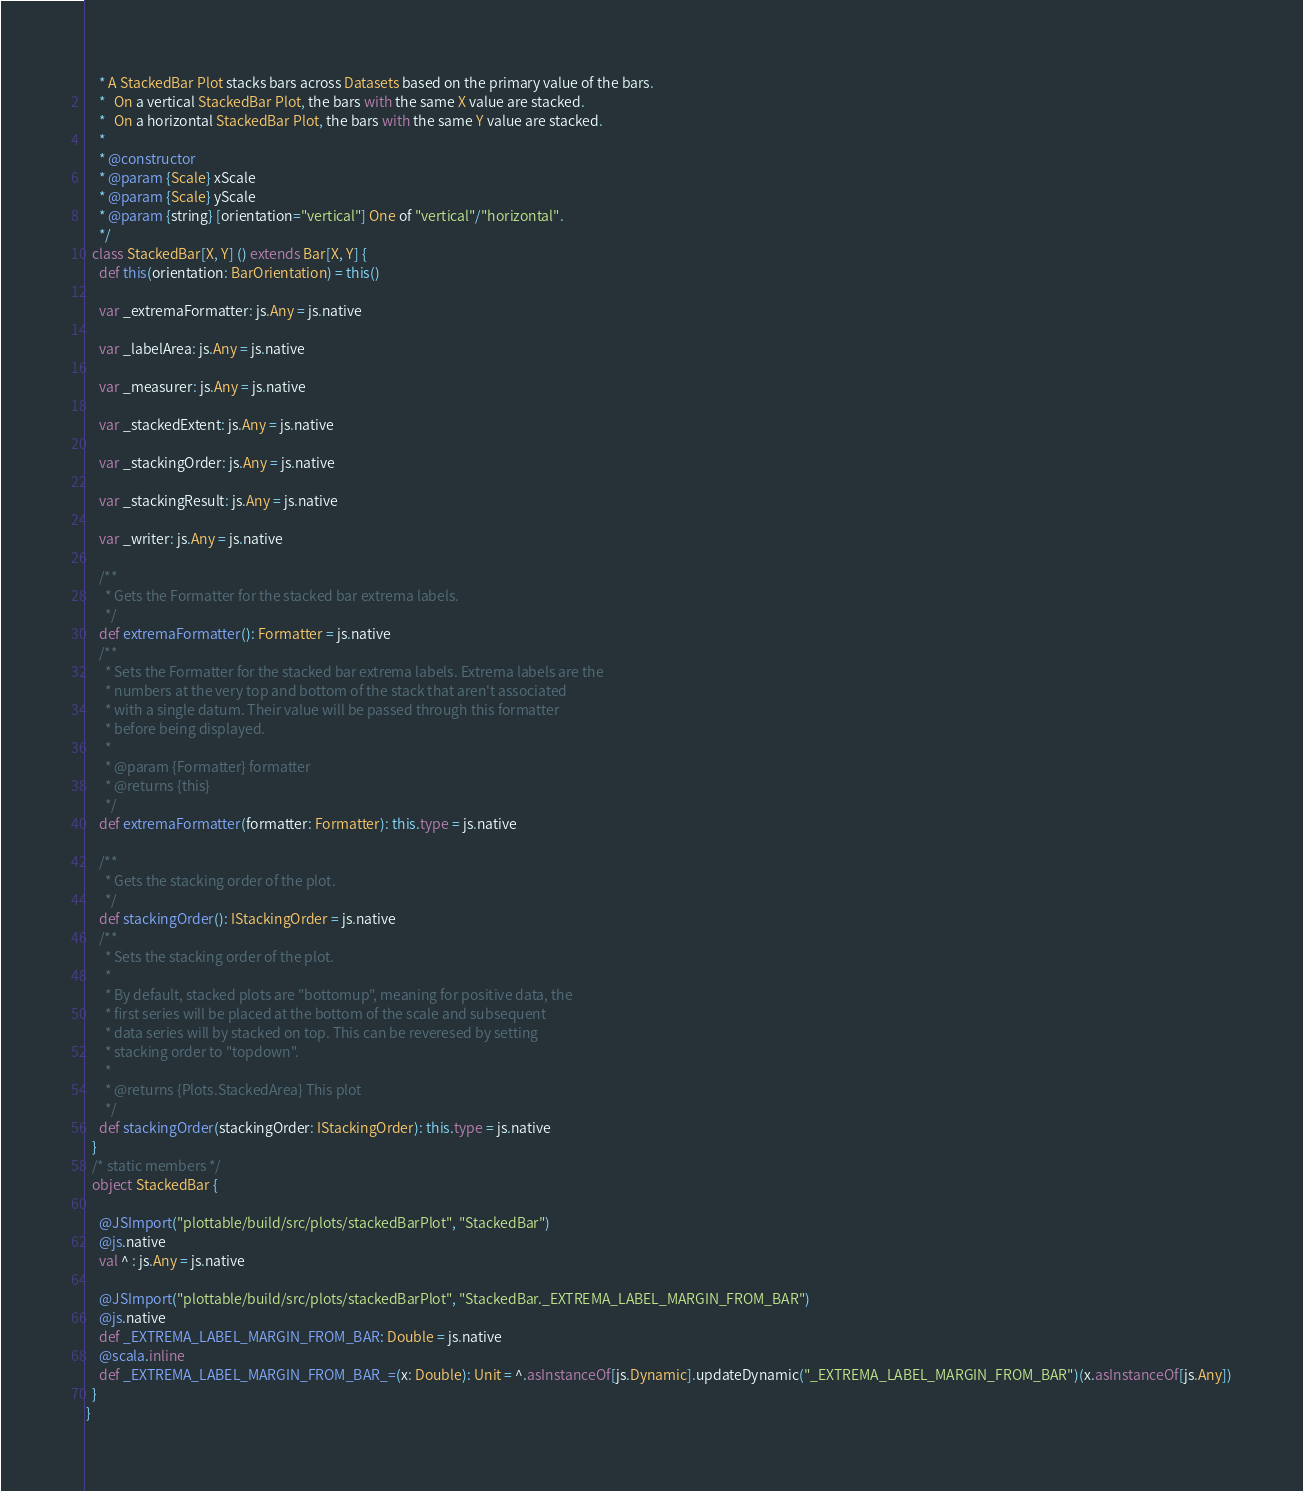<code> <loc_0><loc_0><loc_500><loc_500><_Scala_>    * A StackedBar Plot stacks bars across Datasets based on the primary value of the bars.
    *   On a vertical StackedBar Plot, the bars with the same X value are stacked.
    *   On a horizontal StackedBar Plot, the bars with the same Y value are stacked.
    *
    * @constructor
    * @param {Scale} xScale
    * @param {Scale} yScale
    * @param {string} [orientation="vertical"] One of "vertical"/"horizontal".
    */
  class StackedBar[X, Y] () extends Bar[X, Y] {
    def this(orientation: BarOrientation) = this()
    
    var _extremaFormatter: js.Any = js.native
    
    var _labelArea: js.Any = js.native
    
    var _measurer: js.Any = js.native
    
    var _stackedExtent: js.Any = js.native
    
    var _stackingOrder: js.Any = js.native
    
    var _stackingResult: js.Any = js.native
    
    var _writer: js.Any = js.native
    
    /**
      * Gets the Formatter for the stacked bar extrema labels.
      */
    def extremaFormatter(): Formatter = js.native
    /**
      * Sets the Formatter for the stacked bar extrema labels. Extrema labels are the
      * numbers at the very top and bottom of the stack that aren't associated
      * with a single datum. Their value will be passed through this formatter
      * before being displayed.
      *
      * @param {Formatter} formatter
      * @returns {this}
      */
    def extremaFormatter(formatter: Formatter): this.type = js.native
    
    /**
      * Gets the stacking order of the plot.
      */
    def stackingOrder(): IStackingOrder = js.native
    /**
      * Sets the stacking order of the plot.
      *
      * By default, stacked plots are "bottomup", meaning for positive data, the
      * first series will be placed at the bottom of the scale and subsequent
      * data series will by stacked on top. This can be reveresed by setting
      * stacking order to "topdown".
      *
      * @returns {Plots.StackedArea} This plot
      */
    def stackingOrder(stackingOrder: IStackingOrder): this.type = js.native
  }
  /* static members */
  object StackedBar {
    
    @JSImport("plottable/build/src/plots/stackedBarPlot", "StackedBar")
    @js.native
    val ^ : js.Any = js.native
    
    @JSImport("plottable/build/src/plots/stackedBarPlot", "StackedBar._EXTREMA_LABEL_MARGIN_FROM_BAR")
    @js.native
    def _EXTREMA_LABEL_MARGIN_FROM_BAR: Double = js.native
    @scala.inline
    def _EXTREMA_LABEL_MARGIN_FROM_BAR_=(x: Double): Unit = ^.asInstanceOf[js.Dynamic].updateDynamic("_EXTREMA_LABEL_MARGIN_FROM_BAR")(x.asInstanceOf[js.Any])
  }
}
</code> 